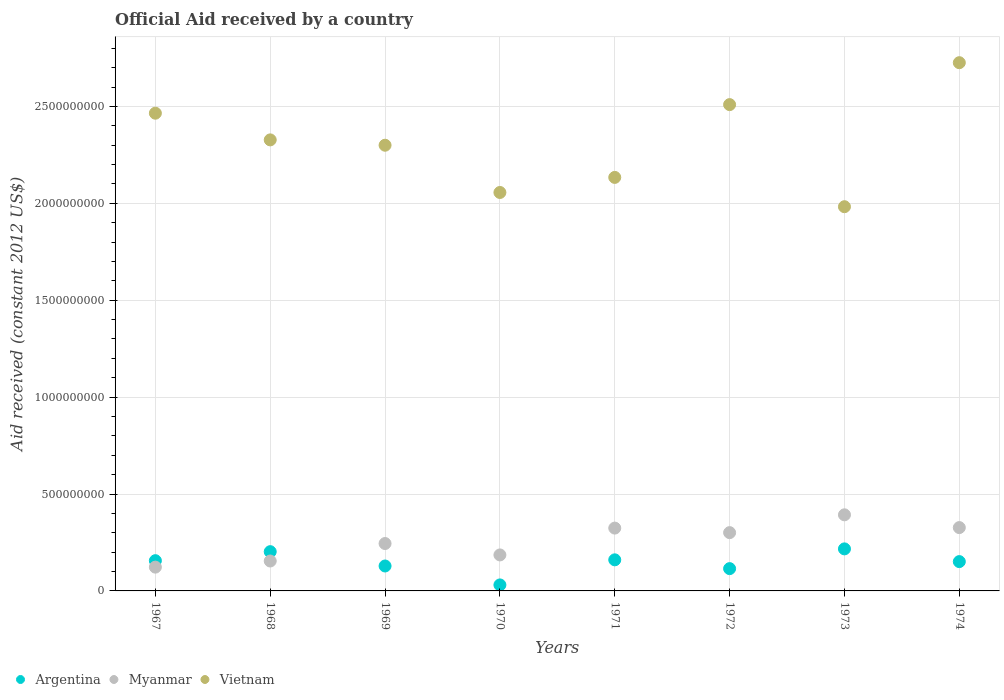How many different coloured dotlines are there?
Give a very brief answer. 3. What is the net official aid received in Myanmar in 1972?
Offer a terse response. 3.01e+08. Across all years, what is the maximum net official aid received in Myanmar?
Make the answer very short. 3.93e+08. Across all years, what is the minimum net official aid received in Argentina?
Give a very brief answer. 3.10e+07. In which year was the net official aid received in Myanmar maximum?
Offer a terse response. 1973. In which year was the net official aid received in Myanmar minimum?
Your answer should be very brief. 1967. What is the total net official aid received in Argentina in the graph?
Offer a very short reply. 1.16e+09. What is the difference between the net official aid received in Myanmar in 1969 and that in 1973?
Offer a terse response. -1.48e+08. What is the difference between the net official aid received in Argentina in 1967 and the net official aid received in Vietnam in 1972?
Provide a succinct answer. -2.35e+09. What is the average net official aid received in Argentina per year?
Provide a succinct answer. 1.45e+08. In the year 1972, what is the difference between the net official aid received in Argentina and net official aid received in Myanmar?
Ensure brevity in your answer.  -1.86e+08. What is the ratio of the net official aid received in Argentina in 1969 to that in 1972?
Ensure brevity in your answer.  1.12. Is the net official aid received in Vietnam in 1968 less than that in 1969?
Give a very brief answer. No. Is the difference between the net official aid received in Argentina in 1967 and 1969 greater than the difference between the net official aid received in Myanmar in 1967 and 1969?
Offer a terse response. Yes. What is the difference between the highest and the second highest net official aid received in Myanmar?
Offer a terse response. 6.59e+07. What is the difference between the highest and the lowest net official aid received in Myanmar?
Give a very brief answer. 2.70e+08. Is the sum of the net official aid received in Myanmar in 1970 and 1973 greater than the maximum net official aid received in Vietnam across all years?
Your answer should be compact. No. Is it the case that in every year, the sum of the net official aid received in Myanmar and net official aid received in Argentina  is greater than the net official aid received in Vietnam?
Keep it short and to the point. No. Does the net official aid received in Argentina monotonically increase over the years?
Keep it short and to the point. No. Is the net official aid received in Vietnam strictly less than the net official aid received in Argentina over the years?
Offer a very short reply. No. How many years are there in the graph?
Give a very brief answer. 8. What is the difference between two consecutive major ticks on the Y-axis?
Offer a very short reply. 5.00e+08. Does the graph contain grids?
Offer a very short reply. Yes. Where does the legend appear in the graph?
Give a very brief answer. Bottom left. What is the title of the graph?
Your response must be concise. Official Aid received by a country. Does "Papua New Guinea" appear as one of the legend labels in the graph?
Ensure brevity in your answer.  No. What is the label or title of the Y-axis?
Provide a short and direct response. Aid received (constant 2012 US$). What is the Aid received (constant 2012 US$) of Argentina in 1967?
Offer a terse response. 1.56e+08. What is the Aid received (constant 2012 US$) in Myanmar in 1967?
Offer a terse response. 1.23e+08. What is the Aid received (constant 2012 US$) of Vietnam in 1967?
Give a very brief answer. 2.47e+09. What is the Aid received (constant 2012 US$) in Argentina in 1968?
Your answer should be compact. 2.03e+08. What is the Aid received (constant 2012 US$) of Myanmar in 1968?
Give a very brief answer. 1.54e+08. What is the Aid received (constant 2012 US$) of Vietnam in 1968?
Your response must be concise. 2.33e+09. What is the Aid received (constant 2012 US$) of Argentina in 1969?
Your answer should be compact. 1.29e+08. What is the Aid received (constant 2012 US$) in Myanmar in 1969?
Provide a short and direct response. 2.45e+08. What is the Aid received (constant 2012 US$) in Vietnam in 1969?
Your response must be concise. 2.30e+09. What is the Aid received (constant 2012 US$) in Argentina in 1970?
Make the answer very short. 3.10e+07. What is the Aid received (constant 2012 US$) in Myanmar in 1970?
Your answer should be compact. 1.86e+08. What is the Aid received (constant 2012 US$) in Vietnam in 1970?
Your response must be concise. 2.06e+09. What is the Aid received (constant 2012 US$) of Argentina in 1971?
Your answer should be very brief. 1.60e+08. What is the Aid received (constant 2012 US$) in Myanmar in 1971?
Provide a succinct answer. 3.24e+08. What is the Aid received (constant 2012 US$) in Vietnam in 1971?
Give a very brief answer. 2.13e+09. What is the Aid received (constant 2012 US$) of Argentina in 1972?
Your answer should be very brief. 1.15e+08. What is the Aid received (constant 2012 US$) in Myanmar in 1972?
Keep it short and to the point. 3.01e+08. What is the Aid received (constant 2012 US$) in Vietnam in 1972?
Offer a very short reply. 2.51e+09. What is the Aid received (constant 2012 US$) of Argentina in 1973?
Offer a terse response. 2.17e+08. What is the Aid received (constant 2012 US$) in Myanmar in 1973?
Give a very brief answer. 3.93e+08. What is the Aid received (constant 2012 US$) of Vietnam in 1973?
Provide a short and direct response. 1.98e+09. What is the Aid received (constant 2012 US$) in Argentina in 1974?
Give a very brief answer. 1.51e+08. What is the Aid received (constant 2012 US$) of Myanmar in 1974?
Your answer should be compact. 3.27e+08. What is the Aid received (constant 2012 US$) in Vietnam in 1974?
Offer a very short reply. 2.73e+09. Across all years, what is the maximum Aid received (constant 2012 US$) of Argentina?
Provide a short and direct response. 2.17e+08. Across all years, what is the maximum Aid received (constant 2012 US$) of Myanmar?
Your answer should be compact. 3.93e+08. Across all years, what is the maximum Aid received (constant 2012 US$) of Vietnam?
Offer a very short reply. 2.73e+09. Across all years, what is the minimum Aid received (constant 2012 US$) of Argentina?
Ensure brevity in your answer.  3.10e+07. Across all years, what is the minimum Aid received (constant 2012 US$) of Myanmar?
Your answer should be very brief. 1.23e+08. Across all years, what is the minimum Aid received (constant 2012 US$) in Vietnam?
Offer a terse response. 1.98e+09. What is the total Aid received (constant 2012 US$) in Argentina in the graph?
Offer a terse response. 1.16e+09. What is the total Aid received (constant 2012 US$) in Myanmar in the graph?
Your response must be concise. 2.05e+09. What is the total Aid received (constant 2012 US$) in Vietnam in the graph?
Provide a succinct answer. 1.85e+1. What is the difference between the Aid received (constant 2012 US$) of Argentina in 1967 and that in 1968?
Provide a short and direct response. -4.65e+07. What is the difference between the Aid received (constant 2012 US$) of Myanmar in 1967 and that in 1968?
Give a very brief answer. -3.16e+07. What is the difference between the Aid received (constant 2012 US$) of Vietnam in 1967 and that in 1968?
Your answer should be compact. 1.38e+08. What is the difference between the Aid received (constant 2012 US$) in Argentina in 1967 and that in 1969?
Offer a terse response. 2.74e+07. What is the difference between the Aid received (constant 2012 US$) in Myanmar in 1967 and that in 1969?
Offer a very short reply. -1.22e+08. What is the difference between the Aid received (constant 2012 US$) of Vietnam in 1967 and that in 1969?
Offer a very short reply. 1.65e+08. What is the difference between the Aid received (constant 2012 US$) in Argentina in 1967 and that in 1970?
Offer a very short reply. 1.25e+08. What is the difference between the Aid received (constant 2012 US$) of Myanmar in 1967 and that in 1970?
Offer a very short reply. -6.30e+07. What is the difference between the Aid received (constant 2012 US$) of Vietnam in 1967 and that in 1970?
Your answer should be compact. 4.09e+08. What is the difference between the Aid received (constant 2012 US$) of Argentina in 1967 and that in 1971?
Offer a terse response. -4.40e+06. What is the difference between the Aid received (constant 2012 US$) of Myanmar in 1967 and that in 1971?
Offer a very short reply. -2.02e+08. What is the difference between the Aid received (constant 2012 US$) of Vietnam in 1967 and that in 1971?
Give a very brief answer. 3.31e+08. What is the difference between the Aid received (constant 2012 US$) of Argentina in 1967 and that in 1972?
Offer a terse response. 4.10e+07. What is the difference between the Aid received (constant 2012 US$) of Myanmar in 1967 and that in 1972?
Your response must be concise. -1.78e+08. What is the difference between the Aid received (constant 2012 US$) in Vietnam in 1967 and that in 1972?
Give a very brief answer. -4.43e+07. What is the difference between the Aid received (constant 2012 US$) in Argentina in 1967 and that in 1973?
Provide a succinct answer. -6.09e+07. What is the difference between the Aid received (constant 2012 US$) in Myanmar in 1967 and that in 1973?
Your response must be concise. -2.70e+08. What is the difference between the Aid received (constant 2012 US$) in Vietnam in 1967 and that in 1973?
Make the answer very short. 4.83e+08. What is the difference between the Aid received (constant 2012 US$) in Argentina in 1967 and that in 1974?
Keep it short and to the point. 4.76e+06. What is the difference between the Aid received (constant 2012 US$) of Myanmar in 1967 and that in 1974?
Provide a succinct answer. -2.04e+08. What is the difference between the Aid received (constant 2012 US$) in Vietnam in 1967 and that in 1974?
Your response must be concise. -2.61e+08. What is the difference between the Aid received (constant 2012 US$) in Argentina in 1968 and that in 1969?
Make the answer very short. 7.39e+07. What is the difference between the Aid received (constant 2012 US$) of Myanmar in 1968 and that in 1969?
Provide a short and direct response. -9.03e+07. What is the difference between the Aid received (constant 2012 US$) in Vietnam in 1968 and that in 1969?
Your answer should be very brief. 2.76e+07. What is the difference between the Aid received (constant 2012 US$) in Argentina in 1968 and that in 1970?
Your answer should be compact. 1.72e+08. What is the difference between the Aid received (constant 2012 US$) in Myanmar in 1968 and that in 1970?
Ensure brevity in your answer.  -3.14e+07. What is the difference between the Aid received (constant 2012 US$) of Vietnam in 1968 and that in 1970?
Make the answer very short. 2.71e+08. What is the difference between the Aid received (constant 2012 US$) in Argentina in 1968 and that in 1971?
Keep it short and to the point. 4.21e+07. What is the difference between the Aid received (constant 2012 US$) in Myanmar in 1968 and that in 1971?
Ensure brevity in your answer.  -1.70e+08. What is the difference between the Aid received (constant 2012 US$) in Vietnam in 1968 and that in 1971?
Offer a terse response. 1.94e+08. What is the difference between the Aid received (constant 2012 US$) of Argentina in 1968 and that in 1972?
Make the answer very short. 8.75e+07. What is the difference between the Aid received (constant 2012 US$) of Myanmar in 1968 and that in 1972?
Keep it short and to the point. -1.46e+08. What is the difference between the Aid received (constant 2012 US$) in Vietnam in 1968 and that in 1972?
Your answer should be compact. -1.82e+08. What is the difference between the Aid received (constant 2012 US$) in Argentina in 1968 and that in 1973?
Offer a very short reply. -1.44e+07. What is the difference between the Aid received (constant 2012 US$) of Myanmar in 1968 and that in 1973?
Provide a succinct answer. -2.38e+08. What is the difference between the Aid received (constant 2012 US$) of Vietnam in 1968 and that in 1973?
Offer a very short reply. 3.45e+08. What is the difference between the Aid received (constant 2012 US$) of Argentina in 1968 and that in 1974?
Offer a terse response. 5.13e+07. What is the difference between the Aid received (constant 2012 US$) of Myanmar in 1968 and that in 1974?
Provide a succinct answer. -1.72e+08. What is the difference between the Aid received (constant 2012 US$) of Vietnam in 1968 and that in 1974?
Provide a succinct answer. -3.98e+08. What is the difference between the Aid received (constant 2012 US$) in Argentina in 1969 and that in 1970?
Your response must be concise. 9.77e+07. What is the difference between the Aid received (constant 2012 US$) of Myanmar in 1969 and that in 1970?
Keep it short and to the point. 5.89e+07. What is the difference between the Aid received (constant 2012 US$) of Vietnam in 1969 and that in 1970?
Your answer should be compact. 2.44e+08. What is the difference between the Aid received (constant 2012 US$) in Argentina in 1969 and that in 1971?
Offer a terse response. -3.18e+07. What is the difference between the Aid received (constant 2012 US$) in Myanmar in 1969 and that in 1971?
Make the answer very short. -7.96e+07. What is the difference between the Aid received (constant 2012 US$) in Vietnam in 1969 and that in 1971?
Provide a short and direct response. 1.66e+08. What is the difference between the Aid received (constant 2012 US$) of Argentina in 1969 and that in 1972?
Ensure brevity in your answer.  1.36e+07. What is the difference between the Aid received (constant 2012 US$) in Myanmar in 1969 and that in 1972?
Your answer should be very brief. -5.62e+07. What is the difference between the Aid received (constant 2012 US$) in Vietnam in 1969 and that in 1972?
Make the answer very short. -2.10e+08. What is the difference between the Aid received (constant 2012 US$) of Argentina in 1969 and that in 1973?
Your answer should be compact. -8.83e+07. What is the difference between the Aid received (constant 2012 US$) in Myanmar in 1969 and that in 1973?
Provide a succinct answer. -1.48e+08. What is the difference between the Aid received (constant 2012 US$) of Vietnam in 1969 and that in 1973?
Offer a very short reply. 3.17e+08. What is the difference between the Aid received (constant 2012 US$) in Argentina in 1969 and that in 1974?
Give a very brief answer. -2.26e+07. What is the difference between the Aid received (constant 2012 US$) in Myanmar in 1969 and that in 1974?
Provide a short and direct response. -8.22e+07. What is the difference between the Aid received (constant 2012 US$) of Vietnam in 1969 and that in 1974?
Give a very brief answer. -4.26e+08. What is the difference between the Aid received (constant 2012 US$) of Argentina in 1970 and that in 1971?
Make the answer very short. -1.29e+08. What is the difference between the Aid received (constant 2012 US$) of Myanmar in 1970 and that in 1971?
Keep it short and to the point. -1.38e+08. What is the difference between the Aid received (constant 2012 US$) in Vietnam in 1970 and that in 1971?
Your answer should be very brief. -7.78e+07. What is the difference between the Aid received (constant 2012 US$) in Argentina in 1970 and that in 1972?
Offer a very short reply. -8.41e+07. What is the difference between the Aid received (constant 2012 US$) of Myanmar in 1970 and that in 1972?
Offer a very short reply. -1.15e+08. What is the difference between the Aid received (constant 2012 US$) of Vietnam in 1970 and that in 1972?
Provide a short and direct response. -4.53e+08. What is the difference between the Aid received (constant 2012 US$) of Argentina in 1970 and that in 1973?
Make the answer very short. -1.86e+08. What is the difference between the Aid received (constant 2012 US$) in Myanmar in 1970 and that in 1973?
Ensure brevity in your answer.  -2.07e+08. What is the difference between the Aid received (constant 2012 US$) in Vietnam in 1970 and that in 1973?
Your answer should be very brief. 7.34e+07. What is the difference between the Aid received (constant 2012 US$) of Argentina in 1970 and that in 1974?
Your answer should be compact. -1.20e+08. What is the difference between the Aid received (constant 2012 US$) of Myanmar in 1970 and that in 1974?
Provide a short and direct response. -1.41e+08. What is the difference between the Aid received (constant 2012 US$) in Vietnam in 1970 and that in 1974?
Ensure brevity in your answer.  -6.70e+08. What is the difference between the Aid received (constant 2012 US$) in Argentina in 1971 and that in 1972?
Provide a short and direct response. 4.54e+07. What is the difference between the Aid received (constant 2012 US$) of Myanmar in 1971 and that in 1972?
Your answer should be very brief. 2.34e+07. What is the difference between the Aid received (constant 2012 US$) in Vietnam in 1971 and that in 1972?
Offer a very short reply. -3.76e+08. What is the difference between the Aid received (constant 2012 US$) of Argentina in 1971 and that in 1973?
Make the answer very short. -5.65e+07. What is the difference between the Aid received (constant 2012 US$) in Myanmar in 1971 and that in 1973?
Give a very brief answer. -6.85e+07. What is the difference between the Aid received (constant 2012 US$) of Vietnam in 1971 and that in 1973?
Offer a very short reply. 1.51e+08. What is the difference between the Aid received (constant 2012 US$) in Argentina in 1971 and that in 1974?
Your answer should be very brief. 9.16e+06. What is the difference between the Aid received (constant 2012 US$) of Myanmar in 1971 and that in 1974?
Provide a short and direct response. -2.61e+06. What is the difference between the Aid received (constant 2012 US$) of Vietnam in 1971 and that in 1974?
Offer a terse response. -5.92e+08. What is the difference between the Aid received (constant 2012 US$) of Argentina in 1972 and that in 1973?
Keep it short and to the point. -1.02e+08. What is the difference between the Aid received (constant 2012 US$) of Myanmar in 1972 and that in 1973?
Offer a very short reply. -9.20e+07. What is the difference between the Aid received (constant 2012 US$) in Vietnam in 1972 and that in 1973?
Offer a terse response. 5.27e+08. What is the difference between the Aid received (constant 2012 US$) in Argentina in 1972 and that in 1974?
Provide a succinct answer. -3.62e+07. What is the difference between the Aid received (constant 2012 US$) of Myanmar in 1972 and that in 1974?
Your answer should be very brief. -2.61e+07. What is the difference between the Aid received (constant 2012 US$) in Vietnam in 1972 and that in 1974?
Offer a terse response. -2.16e+08. What is the difference between the Aid received (constant 2012 US$) of Argentina in 1973 and that in 1974?
Offer a terse response. 6.57e+07. What is the difference between the Aid received (constant 2012 US$) in Myanmar in 1973 and that in 1974?
Provide a succinct answer. 6.59e+07. What is the difference between the Aid received (constant 2012 US$) of Vietnam in 1973 and that in 1974?
Ensure brevity in your answer.  -7.43e+08. What is the difference between the Aid received (constant 2012 US$) in Argentina in 1967 and the Aid received (constant 2012 US$) in Myanmar in 1968?
Your answer should be very brief. 1.71e+06. What is the difference between the Aid received (constant 2012 US$) of Argentina in 1967 and the Aid received (constant 2012 US$) of Vietnam in 1968?
Provide a succinct answer. -2.17e+09. What is the difference between the Aid received (constant 2012 US$) of Myanmar in 1967 and the Aid received (constant 2012 US$) of Vietnam in 1968?
Ensure brevity in your answer.  -2.20e+09. What is the difference between the Aid received (constant 2012 US$) of Argentina in 1967 and the Aid received (constant 2012 US$) of Myanmar in 1969?
Keep it short and to the point. -8.86e+07. What is the difference between the Aid received (constant 2012 US$) in Argentina in 1967 and the Aid received (constant 2012 US$) in Vietnam in 1969?
Your answer should be compact. -2.14e+09. What is the difference between the Aid received (constant 2012 US$) in Myanmar in 1967 and the Aid received (constant 2012 US$) in Vietnam in 1969?
Offer a terse response. -2.18e+09. What is the difference between the Aid received (constant 2012 US$) of Argentina in 1967 and the Aid received (constant 2012 US$) of Myanmar in 1970?
Give a very brief answer. -2.97e+07. What is the difference between the Aid received (constant 2012 US$) of Argentina in 1967 and the Aid received (constant 2012 US$) of Vietnam in 1970?
Ensure brevity in your answer.  -1.90e+09. What is the difference between the Aid received (constant 2012 US$) in Myanmar in 1967 and the Aid received (constant 2012 US$) in Vietnam in 1970?
Your answer should be compact. -1.93e+09. What is the difference between the Aid received (constant 2012 US$) in Argentina in 1967 and the Aid received (constant 2012 US$) in Myanmar in 1971?
Provide a short and direct response. -1.68e+08. What is the difference between the Aid received (constant 2012 US$) of Argentina in 1967 and the Aid received (constant 2012 US$) of Vietnam in 1971?
Provide a short and direct response. -1.98e+09. What is the difference between the Aid received (constant 2012 US$) in Myanmar in 1967 and the Aid received (constant 2012 US$) in Vietnam in 1971?
Ensure brevity in your answer.  -2.01e+09. What is the difference between the Aid received (constant 2012 US$) of Argentina in 1967 and the Aid received (constant 2012 US$) of Myanmar in 1972?
Your answer should be very brief. -1.45e+08. What is the difference between the Aid received (constant 2012 US$) of Argentina in 1967 and the Aid received (constant 2012 US$) of Vietnam in 1972?
Ensure brevity in your answer.  -2.35e+09. What is the difference between the Aid received (constant 2012 US$) in Myanmar in 1967 and the Aid received (constant 2012 US$) in Vietnam in 1972?
Provide a succinct answer. -2.39e+09. What is the difference between the Aid received (constant 2012 US$) of Argentina in 1967 and the Aid received (constant 2012 US$) of Myanmar in 1973?
Give a very brief answer. -2.37e+08. What is the difference between the Aid received (constant 2012 US$) of Argentina in 1967 and the Aid received (constant 2012 US$) of Vietnam in 1973?
Offer a terse response. -1.83e+09. What is the difference between the Aid received (constant 2012 US$) in Myanmar in 1967 and the Aid received (constant 2012 US$) in Vietnam in 1973?
Your answer should be very brief. -1.86e+09. What is the difference between the Aid received (constant 2012 US$) in Argentina in 1967 and the Aid received (constant 2012 US$) in Myanmar in 1974?
Your answer should be very brief. -1.71e+08. What is the difference between the Aid received (constant 2012 US$) of Argentina in 1967 and the Aid received (constant 2012 US$) of Vietnam in 1974?
Keep it short and to the point. -2.57e+09. What is the difference between the Aid received (constant 2012 US$) in Myanmar in 1967 and the Aid received (constant 2012 US$) in Vietnam in 1974?
Provide a short and direct response. -2.60e+09. What is the difference between the Aid received (constant 2012 US$) in Argentina in 1968 and the Aid received (constant 2012 US$) in Myanmar in 1969?
Ensure brevity in your answer.  -4.20e+07. What is the difference between the Aid received (constant 2012 US$) in Argentina in 1968 and the Aid received (constant 2012 US$) in Vietnam in 1969?
Make the answer very short. -2.10e+09. What is the difference between the Aid received (constant 2012 US$) in Myanmar in 1968 and the Aid received (constant 2012 US$) in Vietnam in 1969?
Provide a short and direct response. -2.15e+09. What is the difference between the Aid received (constant 2012 US$) of Argentina in 1968 and the Aid received (constant 2012 US$) of Myanmar in 1970?
Offer a very short reply. 1.69e+07. What is the difference between the Aid received (constant 2012 US$) in Argentina in 1968 and the Aid received (constant 2012 US$) in Vietnam in 1970?
Keep it short and to the point. -1.85e+09. What is the difference between the Aid received (constant 2012 US$) in Myanmar in 1968 and the Aid received (constant 2012 US$) in Vietnam in 1970?
Ensure brevity in your answer.  -1.90e+09. What is the difference between the Aid received (constant 2012 US$) of Argentina in 1968 and the Aid received (constant 2012 US$) of Myanmar in 1971?
Keep it short and to the point. -1.22e+08. What is the difference between the Aid received (constant 2012 US$) of Argentina in 1968 and the Aid received (constant 2012 US$) of Vietnam in 1971?
Your answer should be very brief. -1.93e+09. What is the difference between the Aid received (constant 2012 US$) in Myanmar in 1968 and the Aid received (constant 2012 US$) in Vietnam in 1971?
Provide a succinct answer. -1.98e+09. What is the difference between the Aid received (constant 2012 US$) of Argentina in 1968 and the Aid received (constant 2012 US$) of Myanmar in 1972?
Keep it short and to the point. -9.82e+07. What is the difference between the Aid received (constant 2012 US$) in Argentina in 1968 and the Aid received (constant 2012 US$) in Vietnam in 1972?
Ensure brevity in your answer.  -2.31e+09. What is the difference between the Aid received (constant 2012 US$) in Myanmar in 1968 and the Aid received (constant 2012 US$) in Vietnam in 1972?
Keep it short and to the point. -2.36e+09. What is the difference between the Aid received (constant 2012 US$) of Argentina in 1968 and the Aid received (constant 2012 US$) of Myanmar in 1973?
Provide a succinct answer. -1.90e+08. What is the difference between the Aid received (constant 2012 US$) of Argentina in 1968 and the Aid received (constant 2012 US$) of Vietnam in 1973?
Provide a succinct answer. -1.78e+09. What is the difference between the Aid received (constant 2012 US$) in Myanmar in 1968 and the Aid received (constant 2012 US$) in Vietnam in 1973?
Your response must be concise. -1.83e+09. What is the difference between the Aid received (constant 2012 US$) of Argentina in 1968 and the Aid received (constant 2012 US$) of Myanmar in 1974?
Your response must be concise. -1.24e+08. What is the difference between the Aid received (constant 2012 US$) of Argentina in 1968 and the Aid received (constant 2012 US$) of Vietnam in 1974?
Ensure brevity in your answer.  -2.52e+09. What is the difference between the Aid received (constant 2012 US$) in Myanmar in 1968 and the Aid received (constant 2012 US$) in Vietnam in 1974?
Your answer should be very brief. -2.57e+09. What is the difference between the Aid received (constant 2012 US$) of Argentina in 1969 and the Aid received (constant 2012 US$) of Myanmar in 1970?
Provide a succinct answer. -5.70e+07. What is the difference between the Aid received (constant 2012 US$) of Argentina in 1969 and the Aid received (constant 2012 US$) of Vietnam in 1970?
Offer a very short reply. -1.93e+09. What is the difference between the Aid received (constant 2012 US$) in Myanmar in 1969 and the Aid received (constant 2012 US$) in Vietnam in 1970?
Make the answer very short. -1.81e+09. What is the difference between the Aid received (constant 2012 US$) in Argentina in 1969 and the Aid received (constant 2012 US$) in Myanmar in 1971?
Make the answer very short. -1.96e+08. What is the difference between the Aid received (constant 2012 US$) in Argentina in 1969 and the Aid received (constant 2012 US$) in Vietnam in 1971?
Ensure brevity in your answer.  -2.01e+09. What is the difference between the Aid received (constant 2012 US$) in Myanmar in 1969 and the Aid received (constant 2012 US$) in Vietnam in 1971?
Your answer should be very brief. -1.89e+09. What is the difference between the Aid received (constant 2012 US$) in Argentina in 1969 and the Aid received (constant 2012 US$) in Myanmar in 1972?
Offer a terse response. -1.72e+08. What is the difference between the Aid received (constant 2012 US$) of Argentina in 1969 and the Aid received (constant 2012 US$) of Vietnam in 1972?
Offer a very short reply. -2.38e+09. What is the difference between the Aid received (constant 2012 US$) of Myanmar in 1969 and the Aid received (constant 2012 US$) of Vietnam in 1972?
Your response must be concise. -2.26e+09. What is the difference between the Aid received (constant 2012 US$) of Argentina in 1969 and the Aid received (constant 2012 US$) of Myanmar in 1973?
Offer a terse response. -2.64e+08. What is the difference between the Aid received (constant 2012 US$) in Argentina in 1969 and the Aid received (constant 2012 US$) in Vietnam in 1973?
Ensure brevity in your answer.  -1.85e+09. What is the difference between the Aid received (constant 2012 US$) in Myanmar in 1969 and the Aid received (constant 2012 US$) in Vietnam in 1973?
Provide a short and direct response. -1.74e+09. What is the difference between the Aid received (constant 2012 US$) of Argentina in 1969 and the Aid received (constant 2012 US$) of Myanmar in 1974?
Give a very brief answer. -1.98e+08. What is the difference between the Aid received (constant 2012 US$) in Argentina in 1969 and the Aid received (constant 2012 US$) in Vietnam in 1974?
Give a very brief answer. -2.60e+09. What is the difference between the Aid received (constant 2012 US$) of Myanmar in 1969 and the Aid received (constant 2012 US$) of Vietnam in 1974?
Ensure brevity in your answer.  -2.48e+09. What is the difference between the Aid received (constant 2012 US$) in Argentina in 1970 and the Aid received (constant 2012 US$) in Myanmar in 1971?
Make the answer very short. -2.93e+08. What is the difference between the Aid received (constant 2012 US$) in Argentina in 1970 and the Aid received (constant 2012 US$) in Vietnam in 1971?
Give a very brief answer. -2.10e+09. What is the difference between the Aid received (constant 2012 US$) in Myanmar in 1970 and the Aid received (constant 2012 US$) in Vietnam in 1971?
Your response must be concise. -1.95e+09. What is the difference between the Aid received (constant 2012 US$) of Argentina in 1970 and the Aid received (constant 2012 US$) of Myanmar in 1972?
Offer a very short reply. -2.70e+08. What is the difference between the Aid received (constant 2012 US$) in Argentina in 1970 and the Aid received (constant 2012 US$) in Vietnam in 1972?
Provide a short and direct response. -2.48e+09. What is the difference between the Aid received (constant 2012 US$) in Myanmar in 1970 and the Aid received (constant 2012 US$) in Vietnam in 1972?
Make the answer very short. -2.32e+09. What is the difference between the Aid received (constant 2012 US$) in Argentina in 1970 and the Aid received (constant 2012 US$) in Myanmar in 1973?
Provide a succinct answer. -3.62e+08. What is the difference between the Aid received (constant 2012 US$) in Argentina in 1970 and the Aid received (constant 2012 US$) in Vietnam in 1973?
Provide a short and direct response. -1.95e+09. What is the difference between the Aid received (constant 2012 US$) of Myanmar in 1970 and the Aid received (constant 2012 US$) of Vietnam in 1973?
Keep it short and to the point. -1.80e+09. What is the difference between the Aid received (constant 2012 US$) of Argentina in 1970 and the Aid received (constant 2012 US$) of Myanmar in 1974?
Offer a terse response. -2.96e+08. What is the difference between the Aid received (constant 2012 US$) of Argentina in 1970 and the Aid received (constant 2012 US$) of Vietnam in 1974?
Your response must be concise. -2.69e+09. What is the difference between the Aid received (constant 2012 US$) in Myanmar in 1970 and the Aid received (constant 2012 US$) in Vietnam in 1974?
Ensure brevity in your answer.  -2.54e+09. What is the difference between the Aid received (constant 2012 US$) of Argentina in 1971 and the Aid received (constant 2012 US$) of Myanmar in 1972?
Provide a short and direct response. -1.40e+08. What is the difference between the Aid received (constant 2012 US$) of Argentina in 1971 and the Aid received (constant 2012 US$) of Vietnam in 1972?
Ensure brevity in your answer.  -2.35e+09. What is the difference between the Aid received (constant 2012 US$) in Myanmar in 1971 and the Aid received (constant 2012 US$) in Vietnam in 1972?
Offer a very short reply. -2.19e+09. What is the difference between the Aid received (constant 2012 US$) in Argentina in 1971 and the Aid received (constant 2012 US$) in Myanmar in 1973?
Your answer should be compact. -2.32e+08. What is the difference between the Aid received (constant 2012 US$) of Argentina in 1971 and the Aid received (constant 2012 US$) of Vietnam in 1973?
Provide a succinct answer. -1.82e+09. What is the difference between the Aid received (constant 2012 US$) in Myanmar in 1971 and the Aid received (constant 2012 US$) in Vietnam in 1973?
Ensure brevity in your answer.  -1.66e+09. What is the difference between the Aid received (constant 2012 US$) of Argentina in 1971 and the Aid received (constant 2012 US$) of Myanmar in 1974?
Offer a very short reply. -1.66e+08. What is the difference between the Aid received (constant 2012 US$) in Argentina in 1971 and the Aid received (constant 2012 US$) in Vietnam in 1974?
Provide a short and direct response. -2.57e+09. What is the difference between the Aid received (constant 2012 US$) of Myanmar in 1971 and the Aid received (constant 2012 US$) of Vietnam in 1974?
Keep it short and to the point. -2.40e+09. What is the difference between the Aid received (constant 2012 US$) in Argentina in 1972 and the Aid received (constant 2012 US$) in Myanmar in 1973?
Give a very brief answer. -2.78e+08. What is the difference between the Aid received (constant 2012 US$) in Argentina in 1972 and the Aid received (constant 2012 US$) in Vietnam in 1973?
Ensure brevity in your answer.  -1.87e+09. What is the difference between the Aid received (constant 2012 US$) of Myanmar in 1972 and the Aid received (constant 2012 US$) of Vietnam in 1973?
Make the answer very short. -1.68e+09. What is the difference between the Aid received (constant 2012 US$) of Argentina in 1972 and the Aid received (constant 2012 US$) of Myanmar in 1974?
Give a very brief answer. -2.12e+08. What is the difference between the Aid received (constant 2012 US$) of Argentina in 1972 and the Aid received (constant 2012 US$) of Vietnam in 1974?
Your response must be concise. -2.61e+09. What is the difference between the Aid received (constant 2012 US$) of Myanmar in 1972 and the Aid received (constant 2012 US$) of Vietnam in 1974?
Keep it short and to the point. -2.43e+09. What is the difference between the Aid received (constant 2012 US$) in Argentina in 1973 and the Aid received (constant 2012 US$) in Myanmar in 1974?
Make the answer very short. -1.10e+08. What is the difference between the Aid received (constant 2012 US$) of Argentina in 1973 and the Aid received (constant 2012 US$) of Vietnam in 1974?
Your response must be concise. -2.51e+09. What is the difference between the Aid received (constant 2012 US$) in Myanmar in 1973 and the Aid received (constant 2012 US$) in Vietnam in 1974?
Offer a very short reply. -2.33e+09. What is the average Aid received (constant 2012 US$) in Argentina per year?
Offer a very short reply. 1.45e+08. What is the average Aid received (constant 2012 US$) of Myanmar per year?
Offer a very short reply. 2.56e+08. What is the average Aid received (constant 2012 US$) of Vietnam per year?
Offer a very short reply. 2.31e+09. In the year 1967, what is the difference between the Aid received (constant 2012 US$) in Argentina and Aid received (constant 2012 US$) in Myanmar?
Offer a very short reply. 3.33e+07. In the year 1967, what is the difference between the Aid received (constant 2012 US$) of Argentina and Aid received (constant 2012 US$) of Vietnam?
Offer a terse response. -2.31e+09. In the year 1967, what is the difference between the Aid received (constant 2012 US$) of Myanmar and Aid received (constant 2012 US$) of Vietnam?
Ensure brevity in your answer.  -2.34e+09. In the year 1968, what is the difference between the Aid received (constant 2012 US$) in Argentina and Aid received (constant 2012 US$) in Myanmar?
Provide a short and direct response. 4.82e+07. In the year 1968, what is the difference between the Aid received (constant 2012 US$) in Argentina and Aid received (constant 2012 US$) in Vietnam?
Offer a very short reply. -2.12e+09. In the year 1968, what is the difference between the Aid received (constant 2012 US$) in Myanmar and Aid received (constant 2012 US$) in Vietnam?
Offer a terse response. -2.17e+09. In the year 1969, what is the difference between the Aid received (constant 2012 US$) in Argentina and Aid received (constant 2012 US$) in Myanmar?
Offer a very short reply. -1.16e+08. In the year 1969, what is the difference between the Aid received (constant 2012 US$) of Argentina and Aid received (constant 2012 US$) of Vietnam?
Your answer should be compact. -2.17e+09. In the year 1969, what is the difference between the Aid received (constant 2012 US$) in Myanmar and Aid received (constant 2012 US$) in Vietnam?
Make the answer very short. -2.06e+09. In the year 1970, what is the difference between the Aid received (constant 2012 US$) of Argentina and Aid received (constant 2012 US$) of Myanmar?
Your response must be concise. -1.55e+08. In the year 1970, what is the difference between the Aid received (constant 2012 US$) of Argentina and Aid received (constant 2012 US$) of Vietnam?
Make the answer very short. -2.03e+09. In the year 1970, what is the difference between the Aid received (constant 2012 US$) of Myanmar and Aid received (constant 2012 US$) of Vietnam?
Your response must be concise. -1.87e+09. In the year 1971, what is the difference between the Aid received (constant 2012 US$) of Argentina and Aid received (constant 2012 US$) of Myanmar?
Make the answer very short. -1.64e+08. In the year 1971, what is the difference between the Aid received (constant 2012 US$) in Argentina and Aid received (constant 2012 US$) in Vietnam?
Keep it short and to the point. -1.97e+09. In the year 1971, what is the difference between the Aid received (constant 2012 US$) of Myanmar and Aid received (constant 2012 US$) of Vietnam?
Your response must be concise. -1.81e+09. In the year 1972, what is the difference between the Aid received (constant 2012 US$) in Argentina and Aid received (constant 2012 US$) in Myanmar?
Your response must be concise. -1.86e+08. In the year 1972, what is the difference between the Aid received (constant 2012 US$) of Argentina and Aid received (constant 2012 US$) of Vietnam?
Your answer should be very brief. -2.39e+09. In the year 1972, what is the difference between the Aid received (constant 2012 US$) in Myanmar and Aid received (constant 2012 US$) in Vietnam?
Your answer should be very brief. -2.21e+09. In the year 1973, what is the difference between the Aid received (constant 2012 US$) in Argentina and Aid received (constant 2012 US$) in Myanmar?
Your answer should be compact. -1.76e+08. In the year 1973, what is the difference between the Aid received (constant 2012 US$) of Argentina and Aid received (constant 2012 US$) of Vietnam?
Give a very brief answer. -1.77e+09. In the year 1973, what is the difference between the Aid received (constant 2012 US$) of Myanmar and Aid received (constant 2012 US$) of Vietnam?
Ensure brevity in your answer.  -1.59e+09. In the year 1974, what is the difference between the Aid received (constant 2012 US$) of Argentina and Aid received (constant 2012 US$) of Myanmar?
Keep it short and to the point. -1.76e+08. In the year 1974, what is the difference between the Aid received (constant 2012 US$) in Argentina and Aid received (constant 2012 US$) in Vietnam?
Your answer should be very brief. -2.57e+09. In the year 1974, what is the difference between the Aid received (constant 2012 US$) of Myanmar and Aid received (constant 2012 US$) of Vietnam?
Offer a terse response. -2.40e+09. What is the ratio of the Aid received (constant 2012 US$) of Argentina in 1967 to that in 1968?
Keep it short and to the point. 0.77. What is the ratio of the Aid received (constant 2012 US$) of Myanmar in 1967 to that in 1968?
Offer a terse response. 0.8. What is the ratio of the Aid received (constant 2012 US$) in Vietnam in 1967 to that in 1968?
Provide a short and direct response. 1.06. What is the ratio of the Aid received (constant 2012 US$) of Argentina in 1967 to that in 1969?
Keep it short and to the point. 1.21. What is the ratio of the Aid received (constant 2012 US$) in Myanmar in 1967 to that in 1969?
Your answer should be compact. 0.5. What is the ratio of the Aid received (constant 2012 US$) in Vietnam in 1967 to that in 1969?
Offer a terse response. 1.07. What is the ratio of the Aid received (constant 2012 US$) in Argentina in 1967 to that in 1970?
Keep it short and to the point. 5.04. What is the ratio of the Aid received (constant 2012 US$) of Myanmar in 1967 to that in 1970?
Offer a terse response. 0.66. What is the ratio of the Aid received (constant 2012 US$) in Vietnam in 1967 to that in 1970?
Keep it short and to the point. 1.2. What is the ratio of the Aid received (constant 2012 US$) in Argentina in 1967 to that in 1971?
Your response must be concise. 0.97. What is the ratio of the Aid received (constant 2012 US$) in Myanmar in 1967 to that in 1971?
Keep it short and to the point. 0.38. What is the ratio of the Aid received (constant 2012 US$) of Vietnam in 1967 to that in 1971?
Your answer should be very brief. 1.16. What is the ratio of the Aid received (constant 2012 US$) of Argentina in 1967 to that in 1972?
Provide a short and direct response. 1.36. What is the ratio of the Aid received (constant 2012 US$) in Myanmar in 1967 to that in 1972?
Offer a very short reply. 0.41. What is the ratio of the Aid received (constant 2012 US$) in Vietnam in 1967 to that in 1972?
Provide a succinct answer. 0.98. What is the ratio of the Aid received (constant 2012 US$) in Argentina in 1967 to that in 1973?
Your response must be concise. 0.72. What is the ratio of the Aid received (constant 2012 US$) of Myanmar in 1967 to that in 1973?
Offer a very short reply. 0.31. What is the ratio of the Aid received (constant 2012 US$) of Vietnam in 1967 to that in 1973?
Your answer should be compact. 1.24. What is the ratio of the Aid received (constant 2012 US$) in Argentina in 1967 to that in 1974?
Keep it short and to the point. 1.03. What is the ratio of the Aid received (constant 2012 US$) in Myanmar in 1967 to that in 1974?
Provide a succinct answer. 0.38. What is the ratio of the Aid received (constant 2012 US$) of Vietnam in 1967 to that in 1974?
Provide a succinct answer. 0.9. What is the ratio of the Aid received (constant 2012 US$) in Argentina in 1968 to that in 1969?
Your response must be concise. 1.57. What is the ratio of the Aid received (constant 2012 US$) of Myanmar in 1968 to that in 1969?
Offer a terse response. 0.63. What is the ratio of the Aid received (constant 2012 US$) of Vietnam in 1968 to that in 1969?
Make the answer very short. 1.01. What is the ratio of the Aid received (constant 2012 US$) of Argentina in 1968 to that in 1970?
Offer a terse response. 6.54. What is the ratio of the Aid received (constant 2012 US$) in Myanmar in 1968 to that in 1970?
Your answer should be compact. 0.83. What is the ratio of the Aid received (constant 2012 US$) in Vietnam in 1968 to that in 1970?
Ensure brevity in your answer.  1.13. What is the ratio of the Aid received (constant 2012 US$) in Argentina in 1968 to that in 1971?
Provide a succinct answer. 1.26. What is the ratio of the Aid received (constant 2012 US$) of Myanmar in 1968 to that in 1971?
Provide a short and direct response. 0.48. What is the ratio of the Aid received (constant 2012 US$) in Vietnam in 1968 to that in 1971?
Provide a short and direct response. 1.09. What is the ratio of the Aid received (constant 2012 US$) of Argentina in 1968 to that in 1972?
Give a very brief answer. 1.76. What is the ratio of the Aid received (constant 2012 US$) of Myanmar in 1968 to that in 1972?
Ensure brevity in your answer.  0.51. What is the ratio of the Aid received (constant 2012 US$) in Vietnam in 1968 to that in 1972?
Your answer should be very brief. 0.93. What is the ratio of the Aid received (constant 2012 US$) of Argentina in 1968 to that in 1973?
Offer a very short reply. 0.93. What is the ratio of the Aid received (constant 2012 US$) of Myanmar in 1968 to that in 1973?
Provide a succinct answer. 0.39. What is the ratio of the Aid received (constant 2012 US$) of Vietnam in 1968 to that in 1973?
Give a very brief answer. 1.17. What is the ratio of the Aid received (constant 2012 US$) in Argentina in 1968 to that in 1974?
Offer a very short reply. 1.34. What is the ratio of the Aid received (constant 2012 US$) in Myanmar in 1968 to that in 1974?
Your answer should be very brief. 0.47. What is the ratio of the Aid received (constant 2012 US$) of Vietnam in 1968 to that in 1974?
Offer a terse response. 0.85. What is the ratio of the Aid received (constant 2012 US$) in Argentina in 1969 to that in 1970?
Offer a very short reply. 4.15. What is the ratio of the Aid received (constant 2012 US$) of Myanmar in 1969 to that in 1970?
Your answer should be compact. 1.32. What is the ratio of the Aid received (constant 2012 US$) in Vietnam in 1969 to that in 1970?
Provide a succinct answer. 1.12. What is the ratio of the Aid received (constant 2012 US$) in Argentina in 1969 to that in 1971?
Provide a short and direct response. 0.8. What is the ratio of the Aid received (constant 2012 US$) in Myanmar in 1969 to that in 1971?
Offer a terse response. 0.75. What is the ratio of the Aid received (constant 2012 US$) in Vietnam in 1969 to that in 1971?
Provide a short and direct response. 1.08. What is the ratio of the Aid received (constant 2012 US$) of Argentina in 1969 to that in 1972?
Make the answer very short. 1.12. What is the ratio of the Aid received (constant 2012 US$) of Myanmar in 1969 to that in 1972?
Make the answer very short. 0.81. What is the ratio of the Aid received (constant 2012 US$) of Vietnam in 1969 to that in 1972?
Give a very brief answer. 0.92. What is the ratio of the Aid received (constant 2012 US$) of Argentina in 1969 to that in 1973?
Provide a short and direct response. 0.59. What is the ratio of the Aid received (constant 2012 US$) in Myanmar in 1969 to that in 1973?
Ensure brevity in your answer.  0.62. What is the ratio of the Aid received (constant 2012 US$) of Vietnam in 1969 to that in 1973?
Your answer should be compact. 1.16. What is the ratio of the Aid received (constant 2012 US$) in Argentina in 1969 to that in 1974?
Provide a succinct answer. 0.85. What is the ratio of the Aid received (constant 2012 US$) in Myanmar in 1969 to that in 1974?
Provide a short and direct response. 0.75. What is the ratio of the Aid received (constant 2012 US$) of Vietnam in 1969 to that in 1974?
Your answer should be compact. 0.84. What is the ratio of the Aid received (constant 2012 US$) of Argentina in 1970 to that in 1971?
Provide a succinct answer. 0.19. What is the ratio of the Aid received (constant 2012 US$) in Myanmar in 1970 to that in 1971?
Offer a terse response. 0.57. What is the ratio of the Aid received (constant 2012 US$) of Vietnam in 1970 to that in 1971?
Make the answer very short. 0.96. What is the ratio of the Aid received (constant 2012 US$) of Argentina in 1970 to that in 1972?
Make the answer very short. 0.27. What is the ratio of the Aid received (constant 2012 US$) of Myanmar in 1970 to that in 1972?
Offer a very short reply. 0.62. What is the ratio of the Aid received (constant 2012 US$) of Vietnam in 1970 to that in 1972?
Provide a succinct answer. 0.82. What is the ratio of the Aid received (constant 2012 US$) of Argentina in 1970 to that in 1973?
Make the answer very short. 0.14. What is the ratio of the Aid received (constant 2012 US$) in Myanmar in 1970 to that in 1973?
Your response must be concise. 0.47. What is the ratio of the Aid received (constant 2012 US$) of Argentina in 1970 to that in 1974?
Give a very brief answer. 0.2. What is the ratio of the Aid received (constant 2012 US$) of Myanmar in 1970 to that in 1974?
Provide a short and direct response. 0.57. What is the ratio of the Aid received (constant 2012 US$) of Vietnam in 1970 to that in 1974?
Make the answer very short. 0.75. What is the ratio of the Aid received (constant 2012 US$) in Argentina in 1971 to that in 1972?
Keep it short and to the point. 1.39. What is the ratio of the Aid received (constant 2012 US$) in Myanmar in 1971 to that in 1972?
Provide a short and direct response. 1.08. What is the ratio of the Aid received (constant 2012 US$) of Vietnam in 1971 to that in 1972?
Offer a terse response. 0.85. What is the ratio of the Aid received (constant 2012 US$) in Argentina in 1971 to that in 1973?
Your response must be concise. 0.74. What is the ratio of the Aid received (constant 2012 US$) of Myanmar in 1971 to that in 1973?
Keep it short and to the point. 0.83. What is the ratio of the Aid received (constant 2012 US$) of Vietnam in 1971 to that in 1973?
Make the answer very short. 1.08. What is the ratio of the Aid received (constant 2012 US$) in Argentina in 1971 to that in 1974?
Offer a very short reply. 1.06. What is the ratio of the Aid received (constant 2012 US$) in Vietnam in 1971 to that in 1974?
Give a very brief answer. 0.78. What is the ratio of the Aid received (constant 2012 US$) of Argentina in 1972 to that in 1973?
Provide a short and direct response. 0.53. What is the ratio of the Aid received (constant 2012 US$) of Myanmar in 1972 to that in 1973?
Offer a very short reply. 0.77. What is the ratio of the Aid received (constant 2012 US$) of Vietnam in 1972 to that in 1973?
Your answer should be very brief. 1.27. What is the ratio of the Aid received (constant 2012 US$) in Argentina in 1972 to that in 1974?
Provide a succinct answer. 0.76. What is the ratio of the Aid received (constant 2012 US$) in Myanmar in 1972 to that in 1974?
Your answer should be compact. 0.92. What is the ratio of the Aid received (constant 2012 US$) of Vietnam in 1972 to that in 1974?
Offer a very short reply. 0.92. What is the ratio of the Aid received (constant 2012 US$) in Argentina in 1973 to that in 1974?
Provide a succinct answer. 1.43. What is the ratio of the Aid received (constant 2012 US$) of Myanmar in 1973 to that in 1974?
Provide a succinct answer. 1.2. What is the ratio of the Aid received (constant 2012 US$) of Vietnam in 1973 to that in 1974?
Provide a succinct answer. 0.73. What is the difference between the highest and the second highest Aid received (constant 2012 US$) of Argentina?
Your answer should be very brief. 1.44e+07. What is the difference between the highest and the second highest Aid received (constant 2012 US$) of Myanmar?
Ensure brevity in your answer.  6.59e+07. What is the difference between the highest and the second highest Aid received (constant 2012 US$) in Vietnam?
Your response must be concise. 2.16e+08. What is the difference between the highest and the lowest Aid received (constant 2012 US$) of Argentina?
Your response must be concise. 1.86e+08. What is the difference between the highest and the lowest Aid received (constant 2012 US$) of Myanmar?
Make the answer very short. 2.70e+08. What is the difference between the highest and the lowest Aid received (constant 2012 US$) in Vietnam?
Provide a succinct answer. 7.43e+08. 